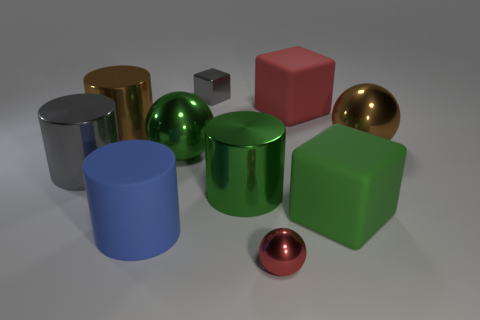There is a rubber object that is the same color as the tiny ball; what is its size?
Make the answer very short. Large. Is the size of the green shiny cylinder that is on the left side of the red shiny thing the same as the gray metallic cube?
Offer a very short reply. No. How many other things are the same color as the matte cylinder?
Your response must be concise. 0. What material is the big red thing?
Give a very brief answer. Rubber. What material is the cube that is both behind the large brown metallic sphere and in front of the small metallic cube?
Make the answer very short. Rubber. What number of objects are metal cylinders that are to the left of the big green cylinder or large green rubber things?
Make the answer very short. 3. Is the color of the small metal block the same as the small sphere?
Keep it short and to the point. No. Is there a red metal object of the same size as the blue matte thing?
Make the answer very short. No. What number of metal spheres are both left of the big green cube and behind the red ball?
Provide a short and direct response. 1. There is a big rubber cylinder; what number of big red objects are in front of it?
Provide a short and direct response. 0. 